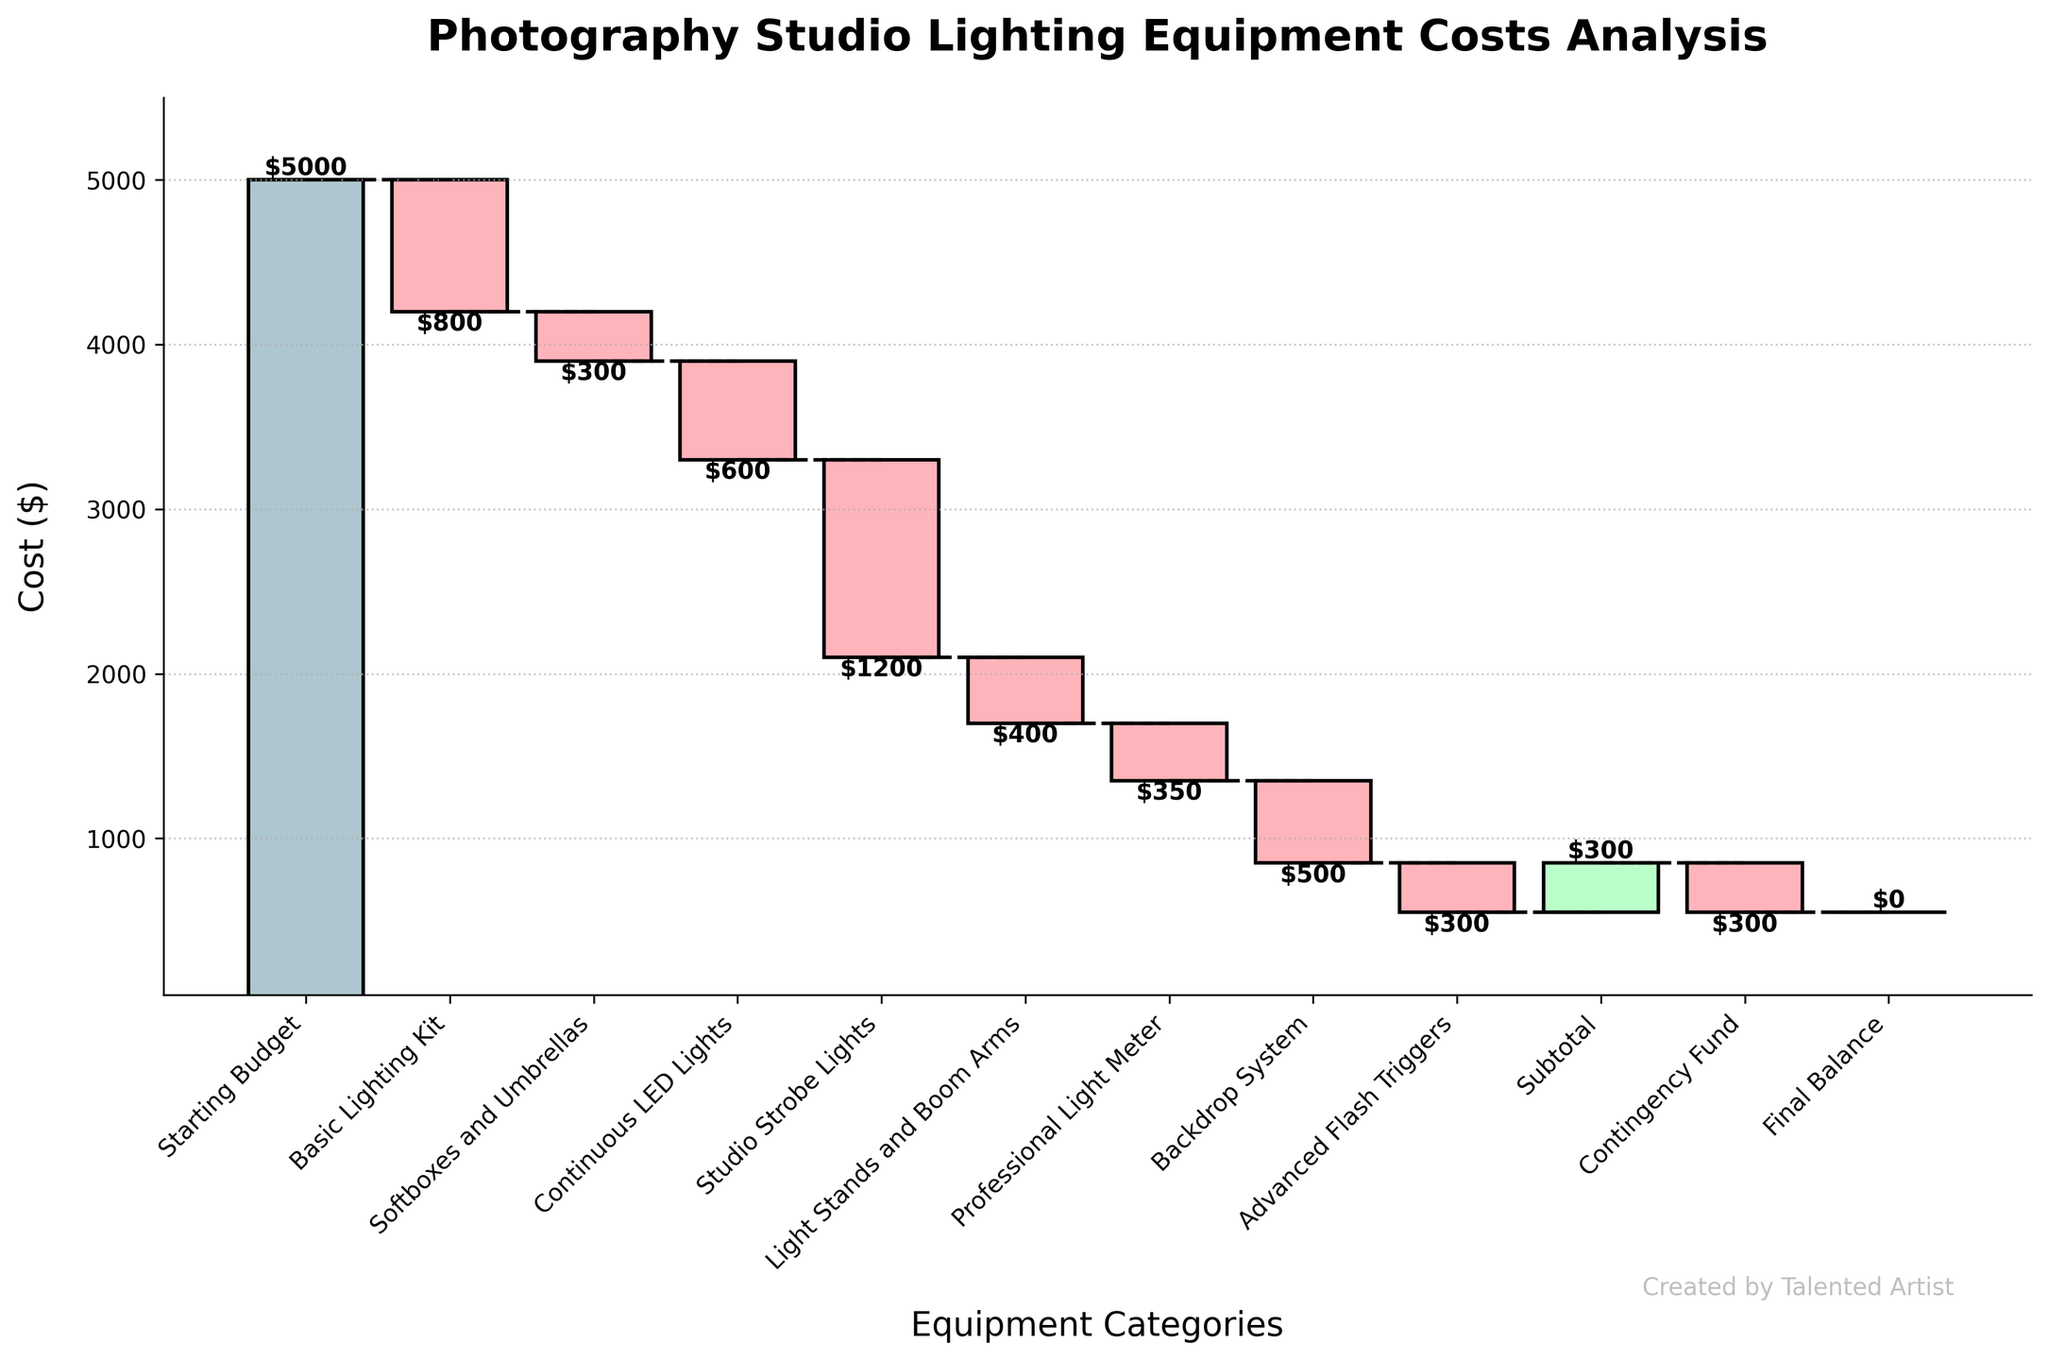What is the title of the chart? The title of the chart is presented at the top of the figure, which provides an overall idea of what the chart is about.
Answer: Photography Studio Lighting Equipment Costs Analysis How many categories of equipment costs are shown in the chart? Count the number of bars representing different categories on the x-axis.
Answer: 11 What is the value of the starting budget? Look at the first bar on the chart and read the label on top of it.
Answer: $5000 Which equipment category incurs the highest cost? Identify the bar with the largest negative value by comparing the lengths of the bars representing negative costs.
Answer: Studio Strobe Lights What is the final balance after all costs and contingency are accounted for? Look at the last bar on the far right and read the value label on top.
Answer: $0 What's the total cost of the basic lighting kit and continuous LED lights? Add the values of the Basic Lighting Kit and Continuous LED Lights by looking at their respective bars. $800 + $600
Answer: $1400 Which costs more, softboxes and umbrellas or light stands and boom arms? Compare the value labels on the bars representing Softboxes and Umbrellas and Light Stands and Boom Arms.
Answer: Light Stands and Boom Arms By how much does the addition of the advanced flash triggers reduce the subtotal? Read the value of the Advanced Flash Triggers bar and subtract it from the subtotal before the reduction. $300
Answer: $300 How much does the backdrop system cost in comparison to the softboxes and umbrellas? Compare the negative values of the Backdrop System and Softboxes and Umbrellas and observe which is more negative.
Answer: Backdrop System costs more What is the cumulative cost before accounting for the contingency fund? Sum of all individual equipment costs (excluding Starting Budget and Contingency Fund), which is reflected in the Subtotal bar. Note the final value at the top of the Subtotal bar.
Answer: $300 